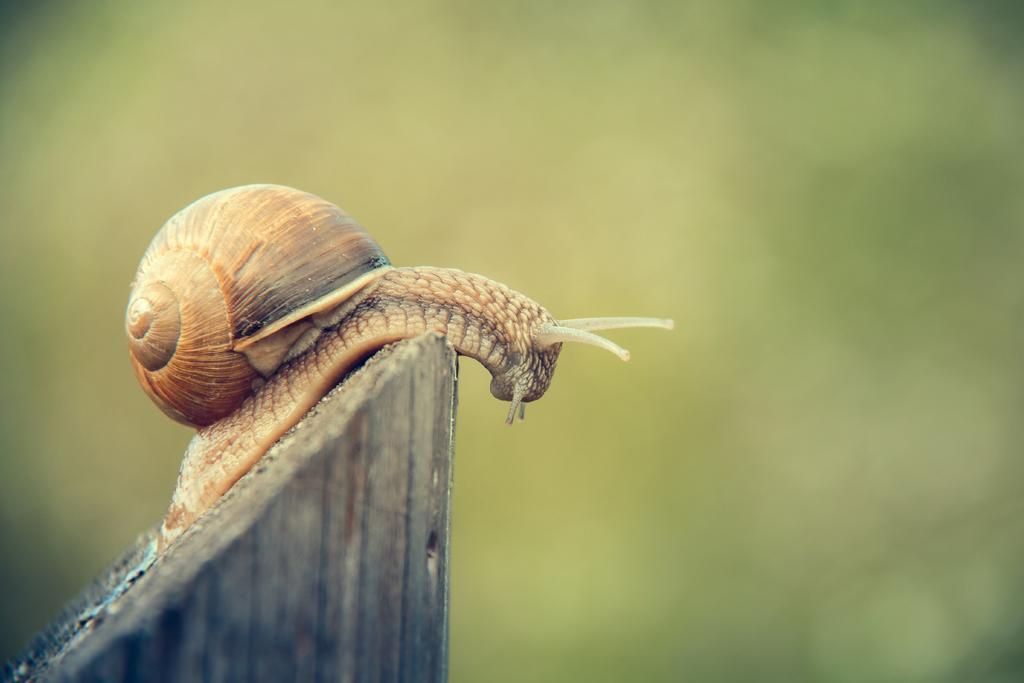Could you give a brief overview of what you see in this image? In this picture we can see a snail on the wooden object. Behind the snail there is the blurred background. 